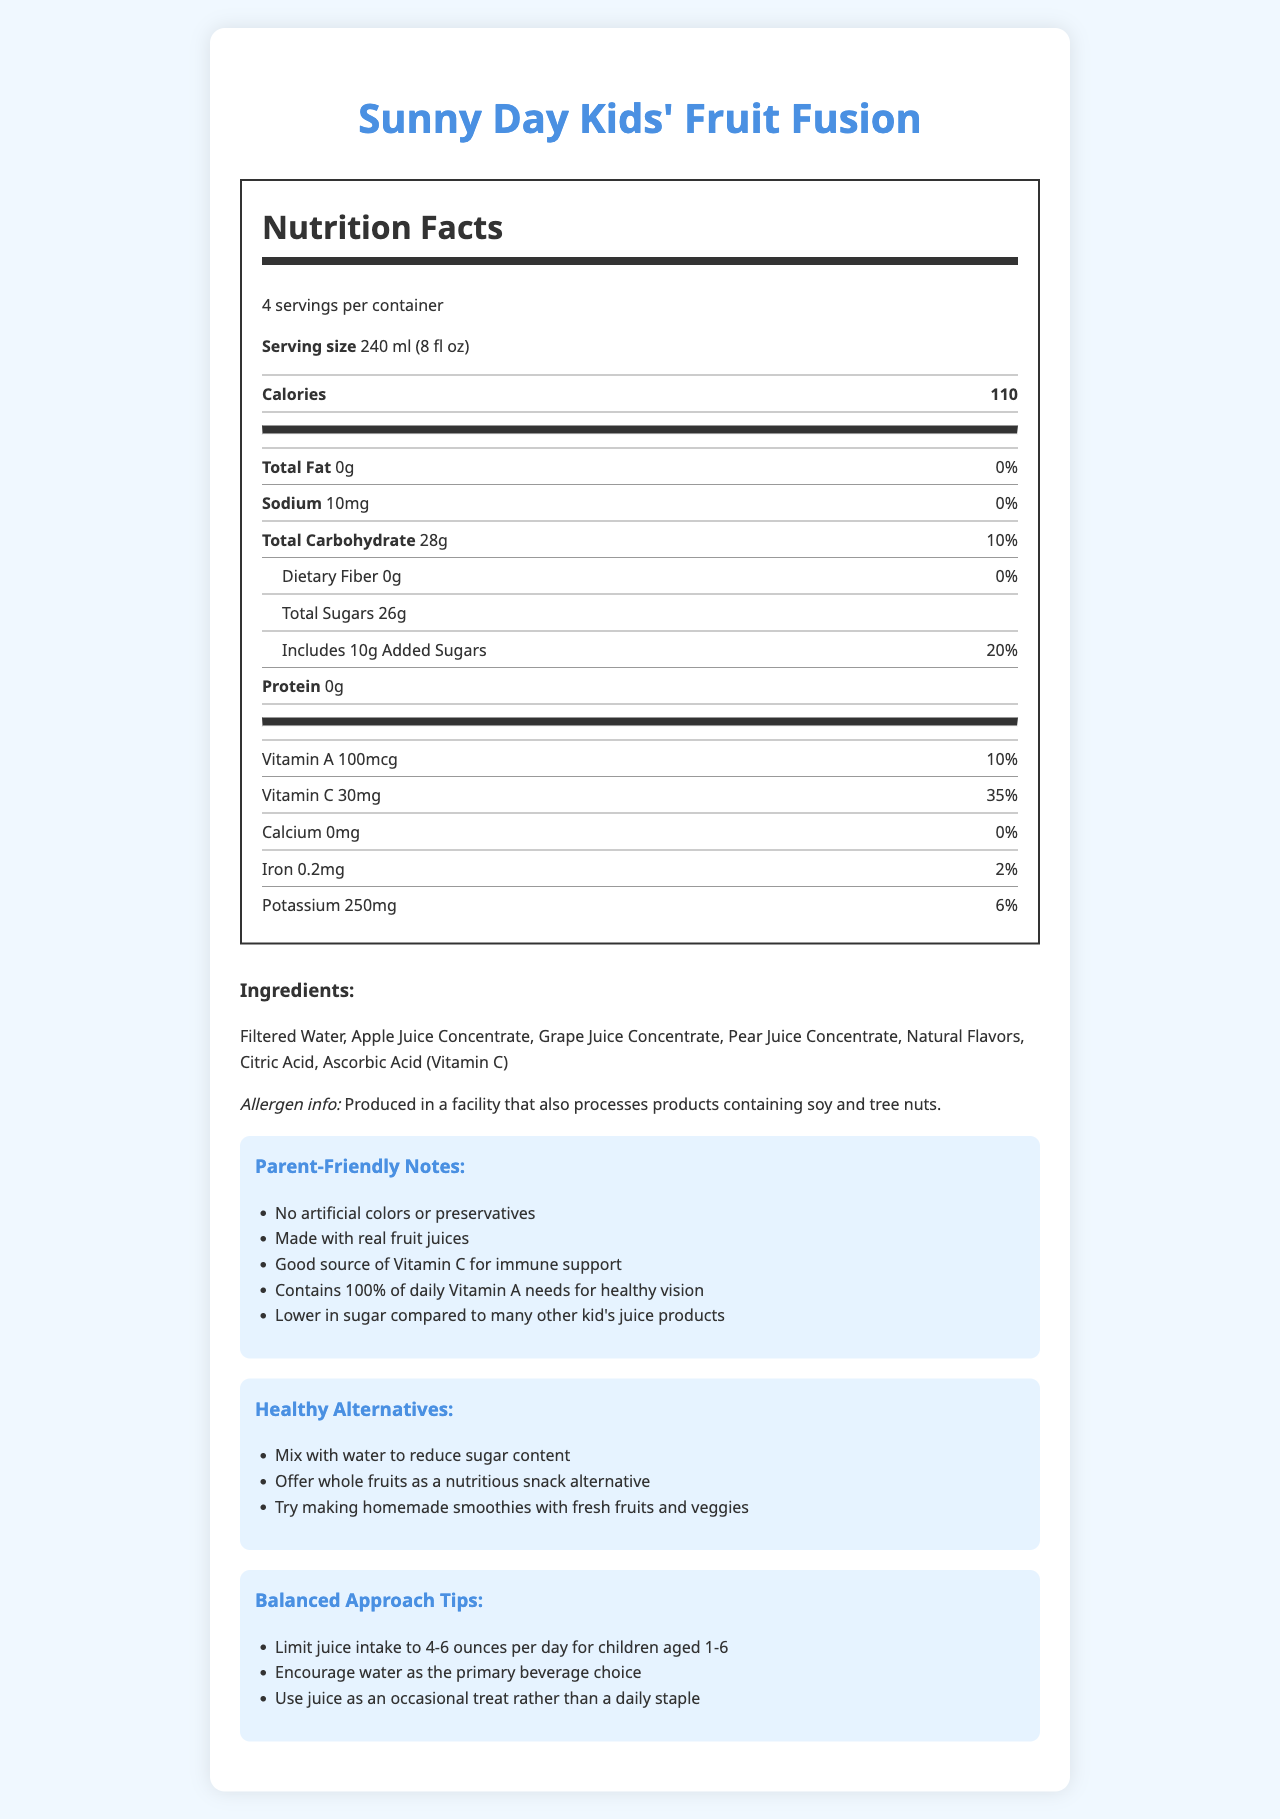what is the serving size? The serving size is listed at the beginning of the Nutrition Facts table.
Answer: 240 ml (8 fl oz) how many servings are in one container of Sunny Day Kids' Fruit Fusion? The label states that there are 4 servings per container.
Answer: 4 how much sodium is in one serving? The sodium content is listed as 10mg for each serving on the Nutrition Facts label.
Answer: 10mg how many grams of total sugar does one serving contain? The total sugar content per serving is listed as 26g on the label.
Answer: 26g which vitamin has the highest daily value percentage? Vitamin C has a daily value of 35%, which is the highest among the vitamins and minerals listed.
Answer: Vitamin C what are the main ingredients in Sunny Day Kids' Fruit Fusion? The main ingredients are listed under the ingredients section.
Answer: Filtered Water, Apple Juice Concentrate, Grape Juice Concentrate, Pear Juice Concentrate, Natural Flavors, Citric Acid, Ascorbic Acid (Vitamin C) how much added sugar is there per serving? A. 8g B. 10g C. 12g D. 14g The label states there are 10g of added sugars per serving.
Answer: B. 10g which of the following is a parent-friendly note on the label? A. Contains caffeine B. Made with real fruit juices C. Artificially flavored D. High in fiber "Made with real fruit juices" is listed in the Parent-Friendly Notes section.
Answer: B. Made with real fruit juices is the product produced in a facility that processes soy and tree nuts? The Allergen Info section mentions that the product is produced in a facility that processes products containing soy and tree nuts.
Answer: Yes summarize the main idea of the document. The document focuses on the nutritional profile and health-related aspects of Sunny Day Kids' Fruit Fusion, offering useful information for parents to help make informed choices for their children.
Answer: This document provides detailed nutritional information for Sunny Day Kids' Fruit Fusion, including serving size, caloric content, vitamins, minerals, and ingredients. It highlights that the product is made from real fruit juices with no artificial colors or preservatives and offers tips for healthier consumption patterns for children. what's the daily value percentage for dietary fiber per serving? According to the label, the dietary fiber content is 0g with a daily value of 0%.
Answer: 0% how many grams of protein are in one serving? The label specifies that there is 0g of protein per serving.
Answer: 0g which ingredient provides Vitamin C in the juice? The ingredient list includes Ascorbic Acid, which is a source of Vitamin C.
Answer: Ascorbic Acid (Vitamin C) is this product a high source of Iron? The product contains 0.2mg of Iron with a daily value of 2%, which is not considered high.
Answer: No are there any artificial colors in Sunny Day Kids' Fruit Fusion? According to the Parent-Friendly Notes section, the product has no artificial colors.
Answer: No how much Potassium is in one serving? The Potassium content is listed as 250mg per serving with a daily value of 6%.
Answer: 250mg does it contain calcium? The label lists 0mg of Calcium with a daily value of 0%.
Answer: No is this juice better than another brand's juice? The document doesn't provide comparative data between this juice and other brands.
Answer: Not enough information 